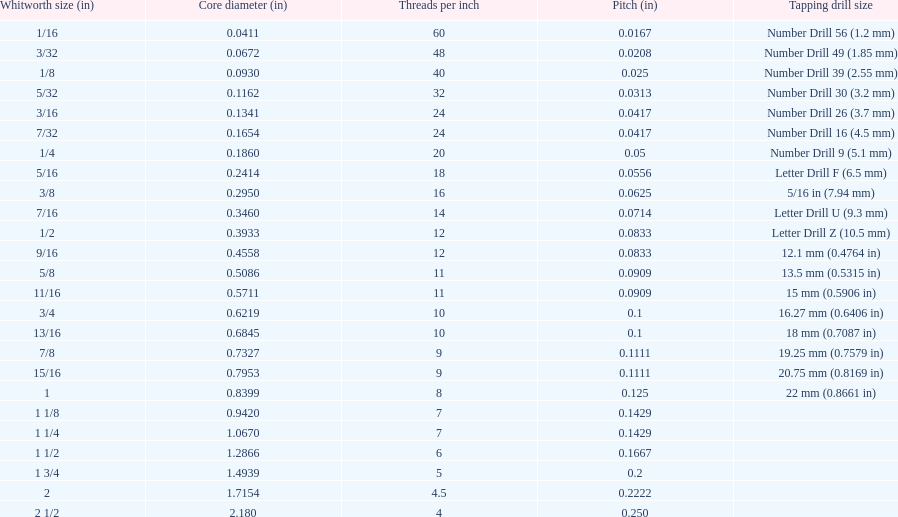Which whitworth size has the same number of threads per inch as 3/16? 7/32. 